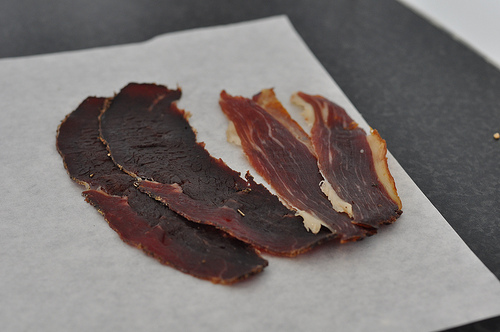<image>
Is there a table above the meat? No. The table is not positioned above the meat. The vertical arrangement shows a different relationship. 